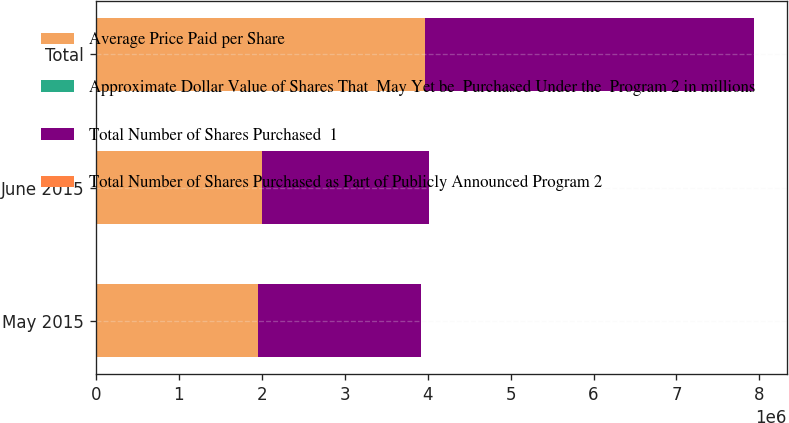Convert chart to OTSL. <chart><loc_0><loc_0><loc_500><loc_500><stacked_bar_chart><ecel><fcel>May 2015<fcel>June 2015<fcel>Total<nl><fcel>Average Price Paid per Share<fcel>1.95976e+06<fcel>2.00665e+06<fcel>3.96656e+06<nl><fcel>Approximate Dollar Value of Shares That  May Yet be  Purchased Under the  Program 2 in millions<fcel>88.1<fcel>88.39<fcel>88.25<nl><fcel>Total Number of Shares Purchased  1<fcel>1.95956e+06<fcel>2.00646e+06<fcel>3.96602e+06<nl><fcel>Total Number of Shares Purchased as Part of Publicly Announced Program 2<fcel>870<fcel>693<fcel>693<nl></chart> 